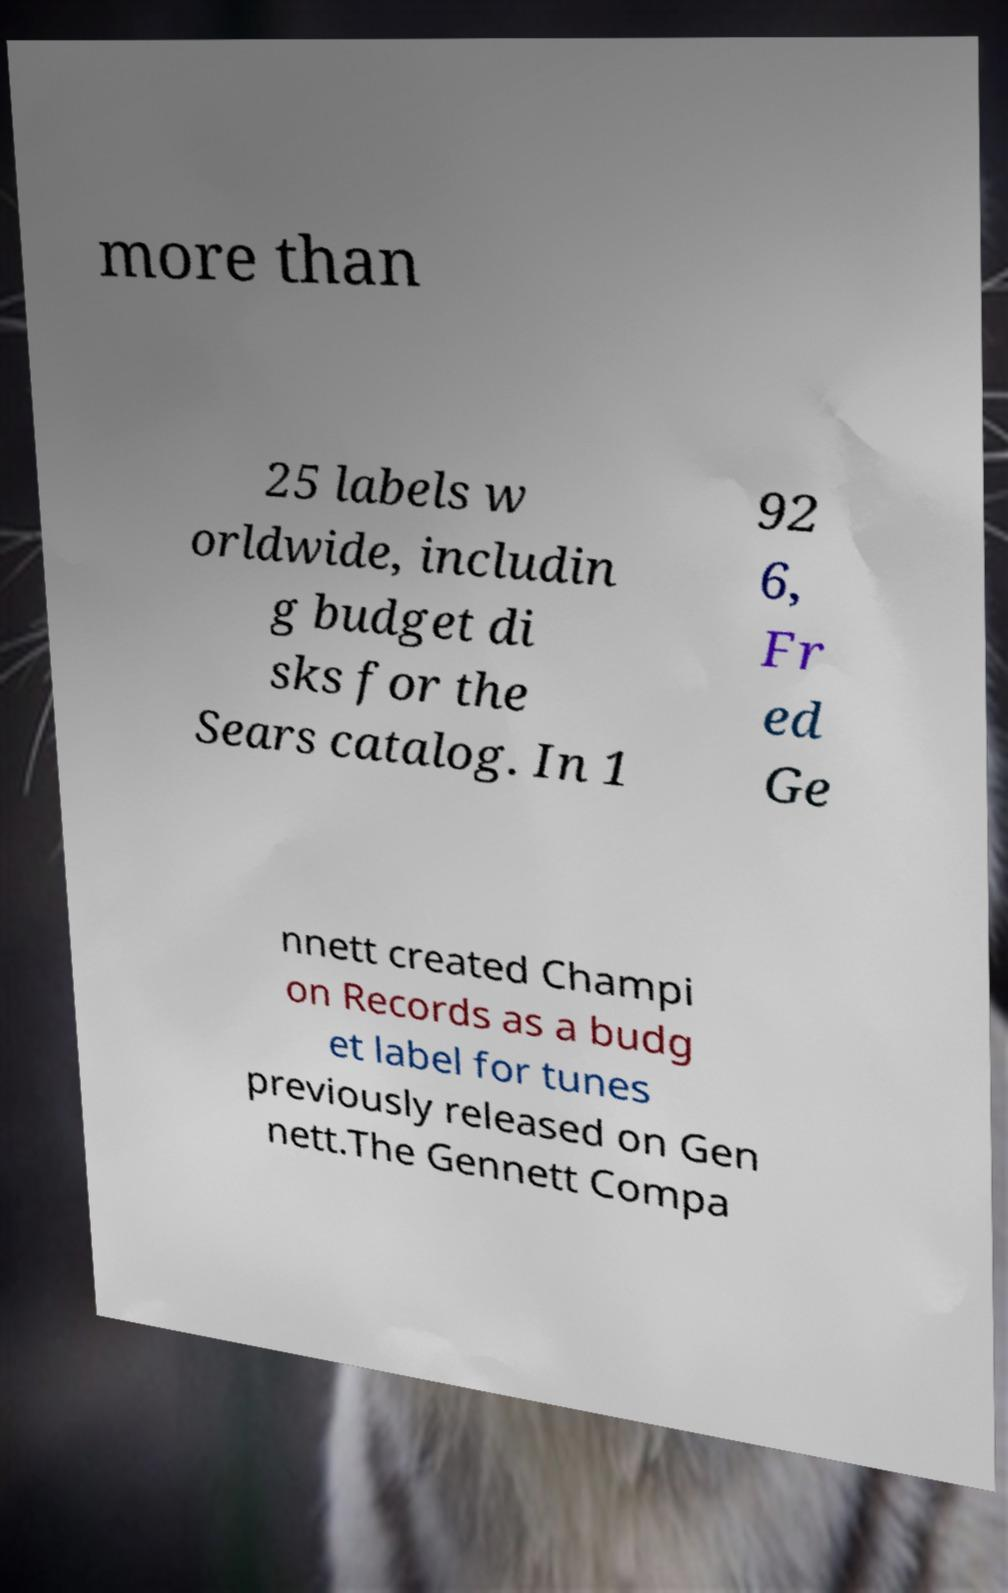For documentation purposes, I need the text within this image transcribed. Could you provide that? more than 25 labels w orldwide, includin g budget di sks for the Sears catalog. In 1 92 6, Fr ed Ge nnett created Champi on Records as a budg et label for tunes previously released on Gen nett.The Gennett Compa 